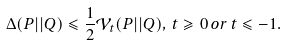Convert formula to latex. <formula><loc_0><loc_0><loc_500><loc_500>\Delta ( P | | Q ) \leqslant \frac { 1 } { 2 } \mathcal { V } _ { t } ( P | | Q ) , \, t \geqslant 0 \, o r \, t \leqslant - 1 .</formula> 